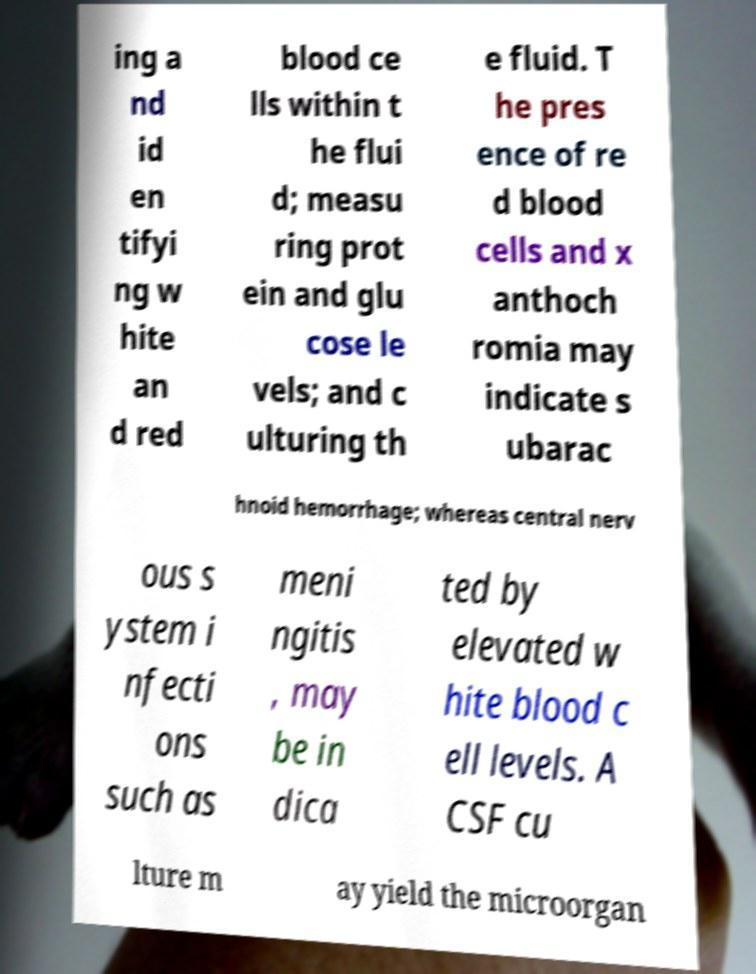Could you extract and type out the text from this image? ing a nd id en tifyi ng w hite an d red blood ce lls within t he flui d; measu ring prot ein and glu cose le vels; and c ulturing th e fluid. T he pres ence of re d blood cells and x anthoch romia may indicate s ubarac hnoid hemorrhage; whereas central nerv ous s ystem i nfecti ons such as meni ngitis , may be in dica ted by elevated w hite blood c ell levels. A CSF cu lture m ay yield the microorgan 